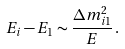<formula> <loc_0><loc_0><loc_500><loc_500>E _ { i } - E _ { 1 } \sim \frac { \Delta { m } _ { i 1 } ^ { 2 } } { E } \, .</formula> 